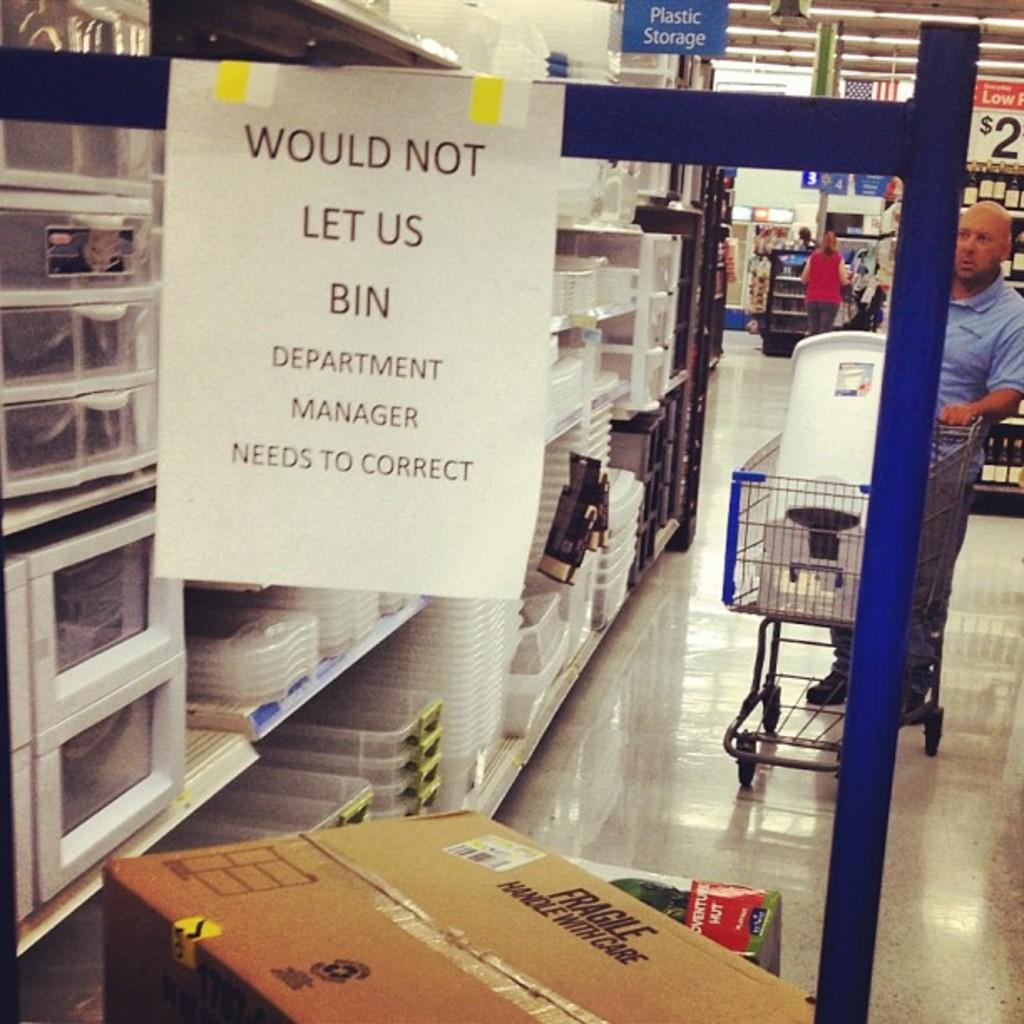<image>
Render a clear and concise summary of the photo. A rack of boxes with a sign that says would not let us bin. 